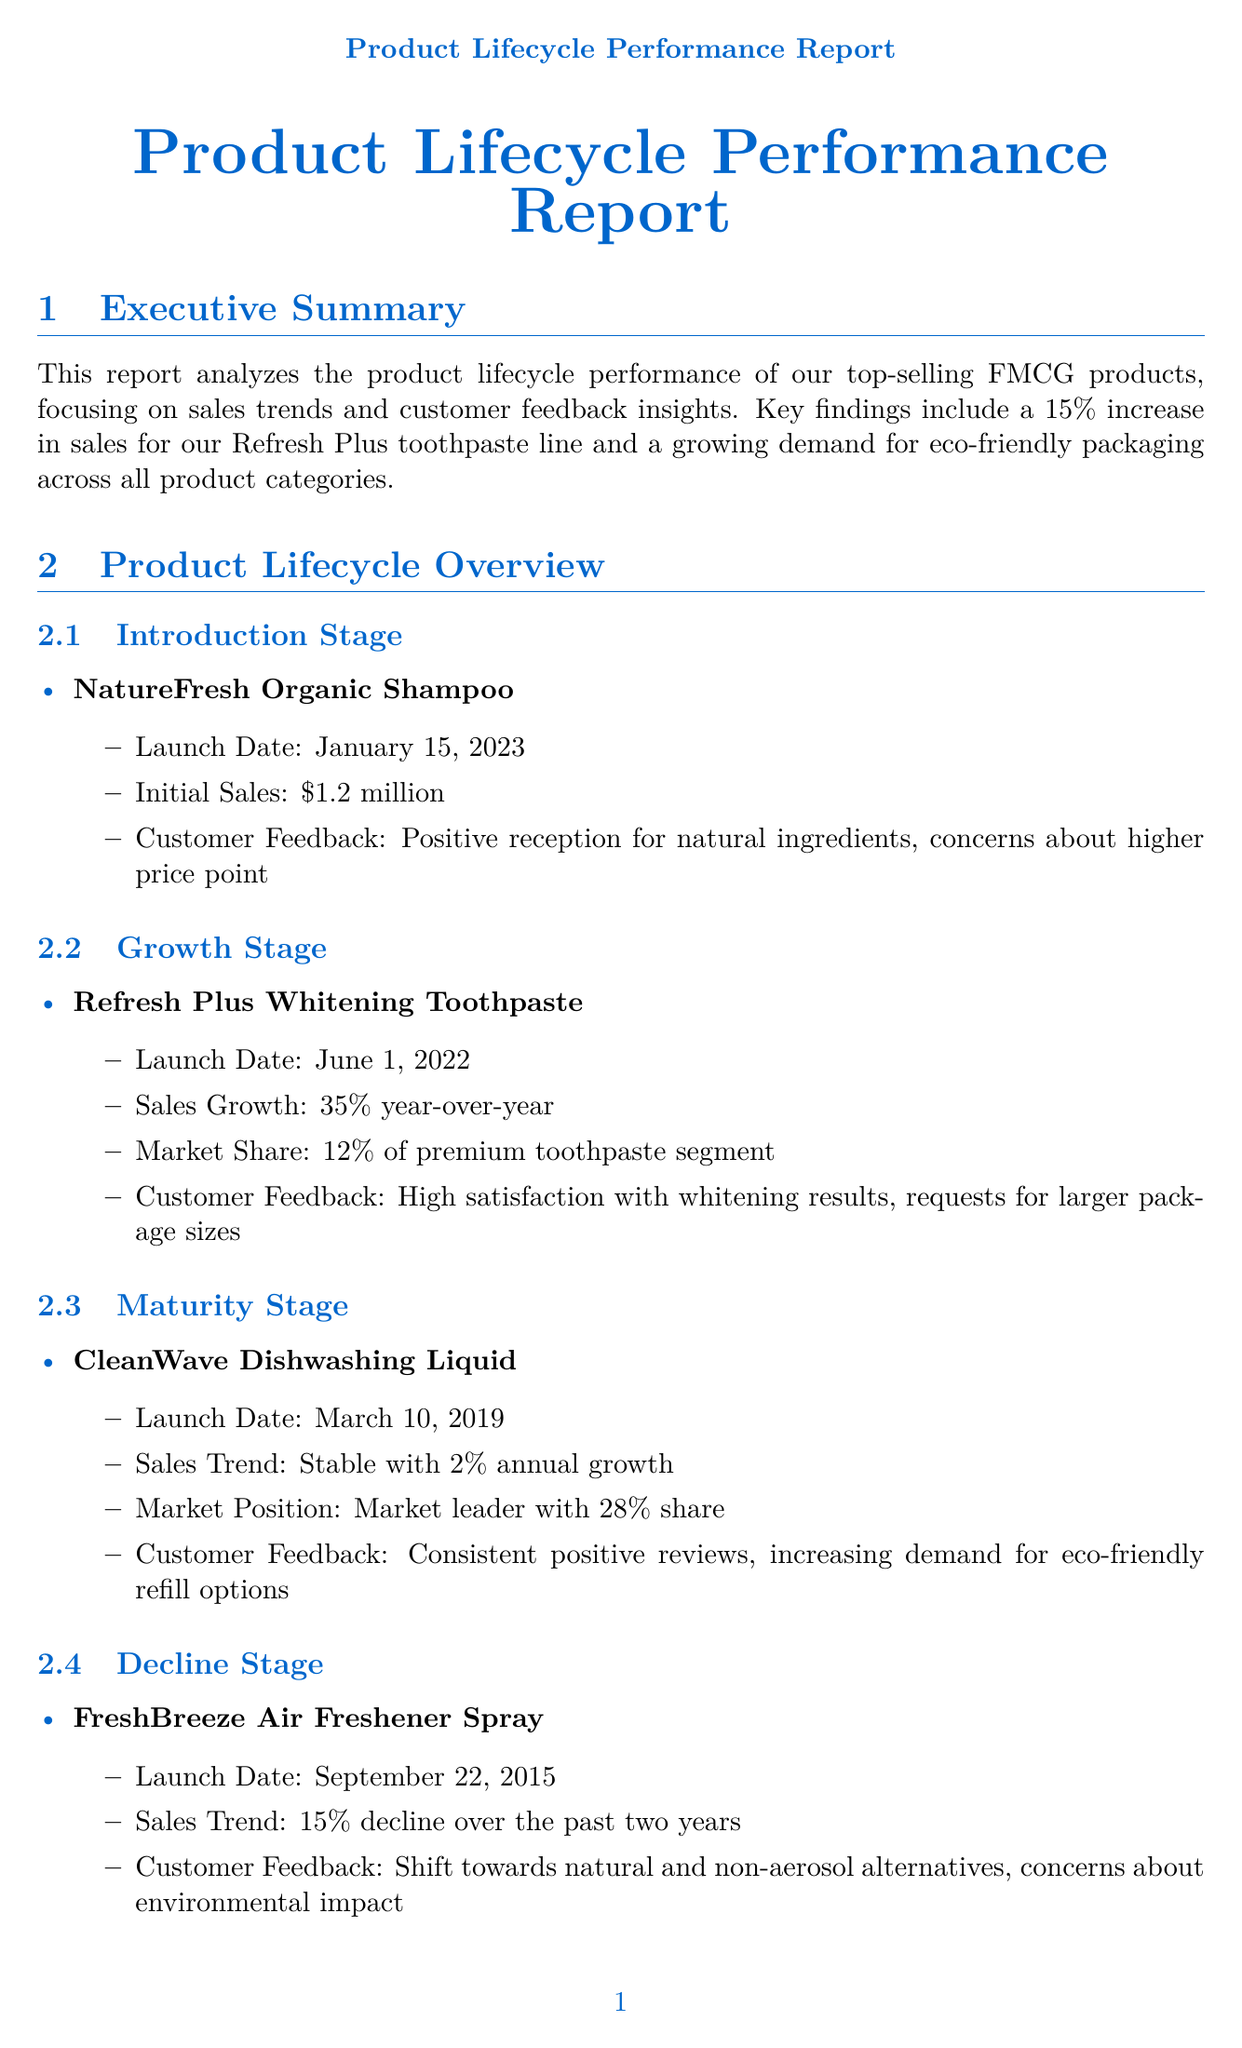What is the sales growth percentage for Refresh Plus Whitening Toothpaste? The sales growth percentage is stated in the Growth Stage section of the document.
Answer: 35% What is the market share of CleanWave Dishwashing Liquid? The market share is listed in the Maturity Stage section as part of its performance metrics.
Answer: 28% When was NatureFresh Organic Shampoo launched? The launch date is provided in the Introduction Stage subsection of the document.
Answer: January 15, 2023 What feedback did customers give regarding packaging? Customer feedback about packaging is detailed in the Customer Feedback Insights section highlighting their preferences.
Answer: 42% of customers express interest in more sustainable packaging options What is the expected impact of introducing value-sized options? This impact is outlined in the Recommendations section detailing how changes will affect pricing strategies.
Answer: Address price sensitivity and increase market share What trend corresponds to a 20% increase in sales? This trend is mentioned in the Sales Trends Analysis section and relates to the overall market performance.
Answer: Shift towards natural and organic products What recommendation is related to product quality? Recommendations about product quality are found in the Recommendations section regarding marketing strategy.
Answer: Emphasize product quality and eco-friendly initiatives in marketing campaigns Which product is in the Decline Stage? This product is discussed in the Decline Stage subsection, highlighting its current sales performance.
Answer: FreshBreeze Air Freshener Spray 